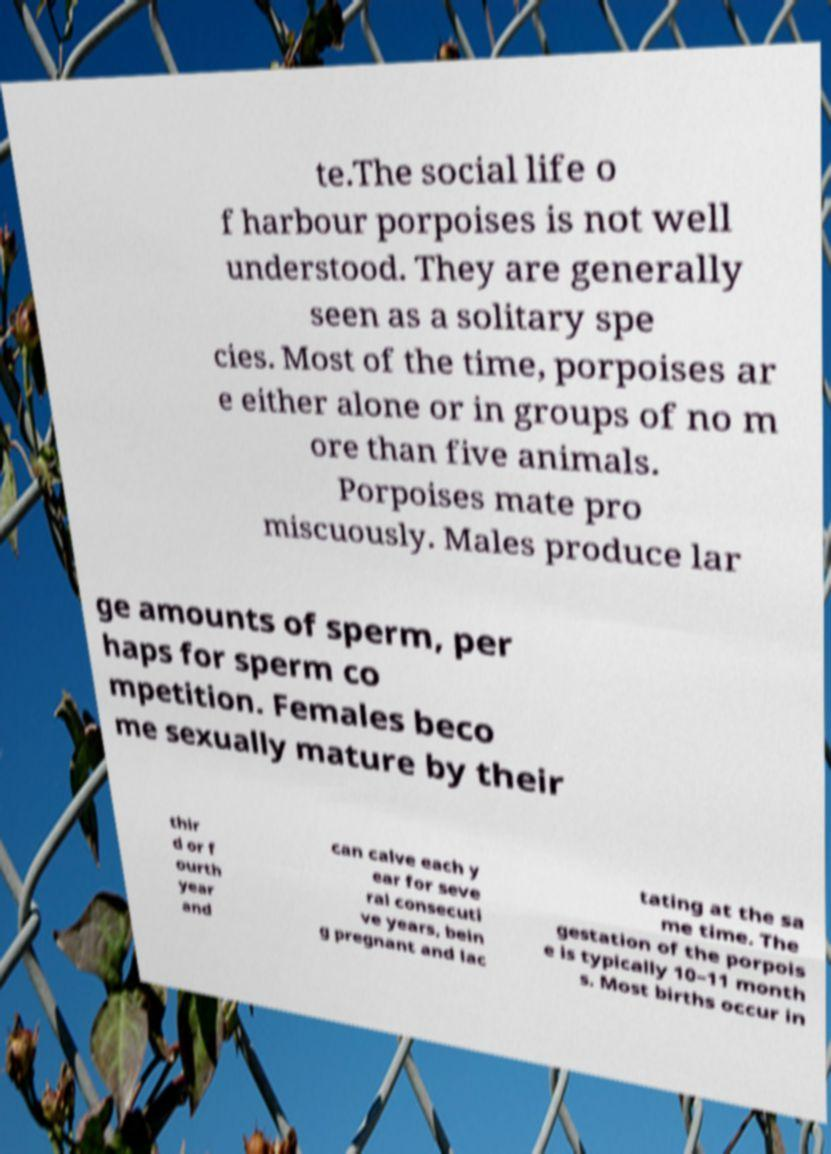I need the written content from this picture converted into text. Can you do that? te.The social life o f harbour porpoises is not well understood. They are generally seen as a solitary spe cies. Most of the time, porpoises ar e either alone or in groups of no m ore than five animals. Porpoises mate pro miscuously. Males produce lar ge amounts of sperm, per haps for sperm co mpetition. Females beco me sexually mature by their thir d or f ourth year and can calve each y ear for seve ral consecuti ve years, bein g pregnant and lac tating at the sa me time. The gestation of the porpois e is typically 10–11 month s. Most births occur in 